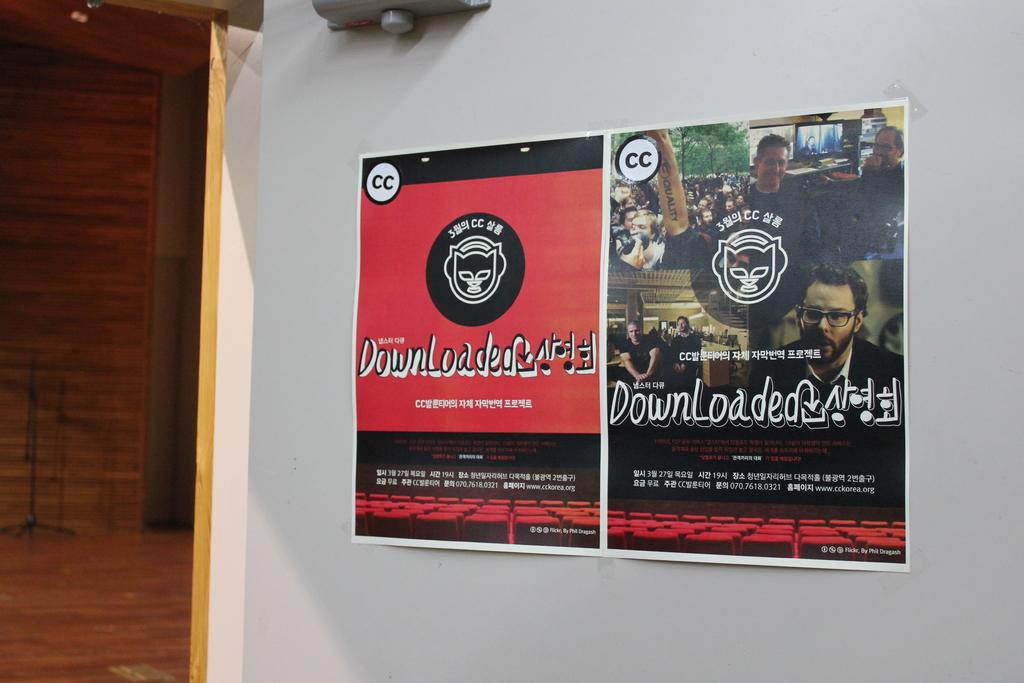<image>
Provide a brief description of the given image. Red poster on the wall with the word Downloaded in the middle. 